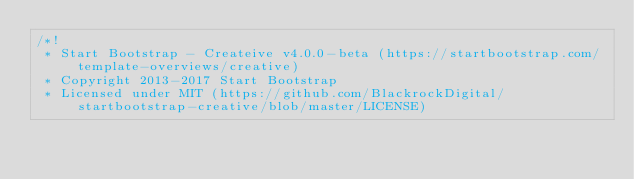<code> <loc_0><loc_0><loc_500><loc_500><_CSS_>/*!
 * Start Bootstrap - Createive v4.0.0-beta (https://startbootstrap.com/template-overviews/creative)
 * Copyright 2013-2017 Start Bootstrap
 * Licensed under MIT (https://github.com/BlackrockDigital/startbootstrap-creative/blob/master/LICENSE)</code> 